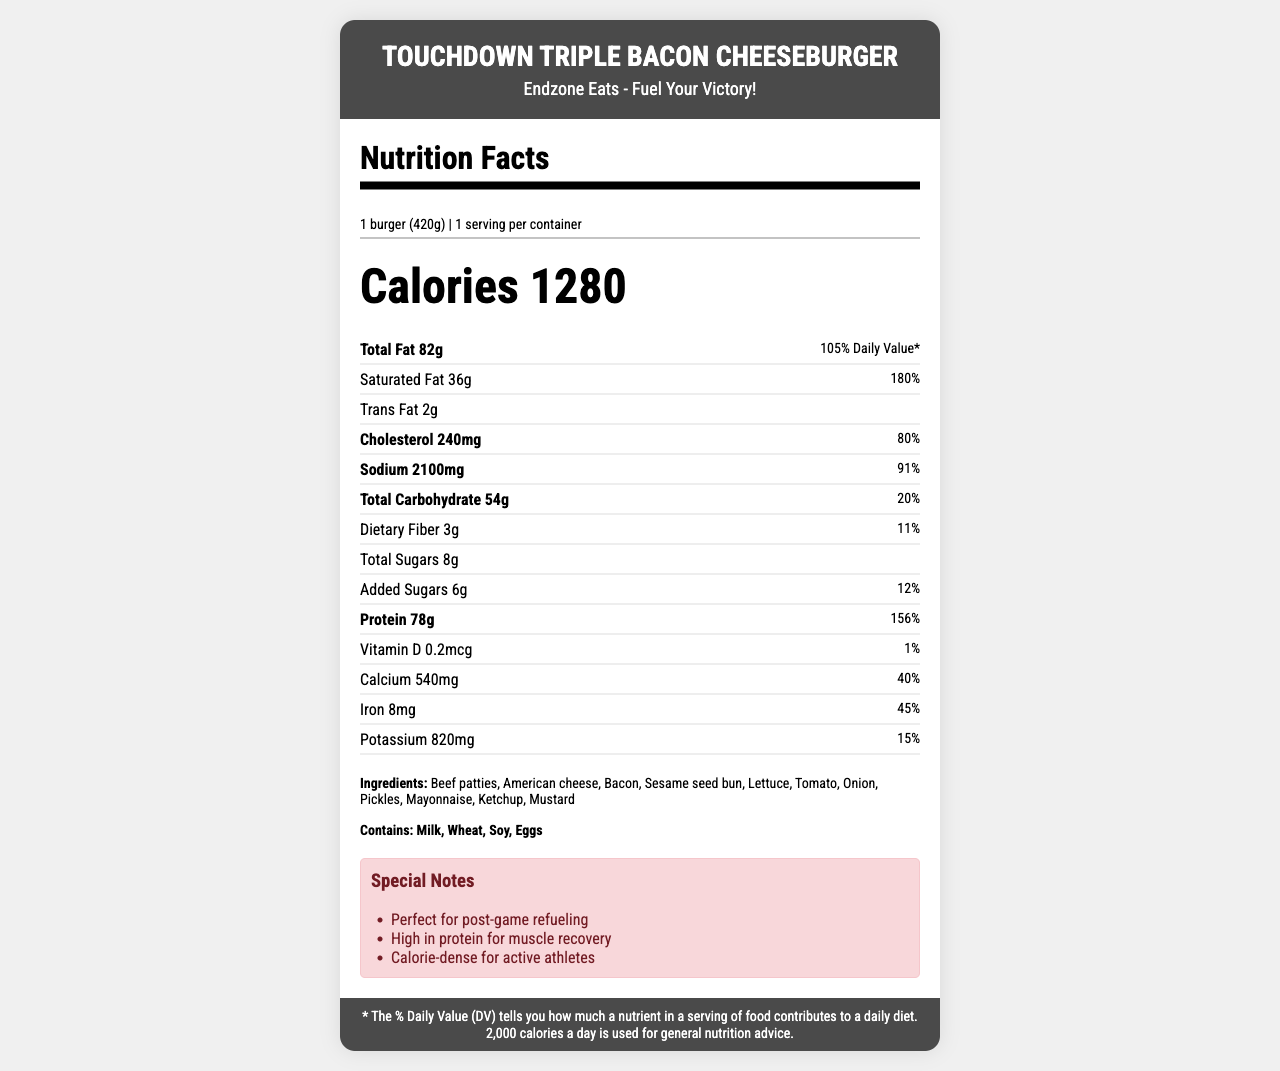what is the serving size of the Touchdown Triple Bacon Cheeseburger? The serving size is clearly stated just below the product name in the document.
Answer: 1 burger (420g) how many grams of protein does the Triple Cheeseburger contain? The protein content is listed in the nutrient section as 78 grams.
Answer: 78g What is the main component of dietary significance for athletes highlighted in the special notes? The special notes mention that the burger is high in protein, which is crucial for muscle recovery in athletes.
Answer: High in protein for muscle recovery What is the total calorie content of the burger? The total calorie content is prominently displayed in large font in the middle of the document.
Answer: 1280 calories What is the percentage of daily value for cholesterol in the burger? The cholesterol daily value percentage is listed next to the amount, which is 240mg equating to 80%.
Answer: 80% How much saturated fat is in the burger? The saturated fat content is specified right below the total fat, listed as 36 grams.
Answer: 36g Which of the following allergens are present in the burger? A. Peanuts B. Fish C. Wheat D. Shellfish The allergens listed in the document include Milk, Wheat, Soy, and Eggs, which makes Wheat the correct answer.
Answer: C How many servings are per container for this burger? A. 1 B. 2 C. 3 D. 4 The serving info section specifies that there is 1 serving per container.
Answer: A Is this burger recommended for post-game refueling according to the special notes? The special notes explicitly state that the burger is "Perfect for post-game refueling."
Answer: Yes Summarize the nutritional highlights of the Touchdown Triple Bacon Cheeseburger. The document contains detailed nutritional information, highlighting its high protein and calorie content, which is beneficial for muscle recovery and refueling.
Answer: The Touchdown Triple Bacon Cheeseburger provides 1280 calories, 82g of total fat, 36g of saturated fat, 78g of protein, and contains allergens like Milk, Wheat, Soy, and Eggs. It is high in protein, making it suitable for muscle recovery and is considered calorie-dense for active athletes. Would you recommend this burger for someone on a low sodium diet? The burger contains 2100mg of sodium, which is 91% of the daily value, making it unsuitable for someone aiming to reduce sodium intake.
Answer: No What is the daily value percentage of dietary fiber in this burger? The daily value percentage for dietary fiber is listed as 11%, based on the 3 grams present in the burger.
Answer: 11% Where is the restaurant that offers the Touchdown Triple Bacon Cheeseburger? The document provides the name of the restaurant, "Endzone Eats," but does not offer specific location details.
Answer: Cannot be determined 